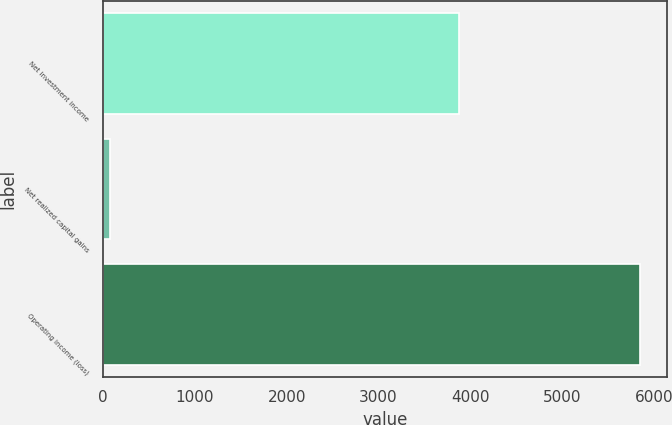Convert chart to OTSL. <chart><loc_0><loc_0><loc_500><loc_500><bar_chart><fcel>Net investment income<fcel>Net realized capital gains<fcel>Operating income (loss)<nl><fcel>3879<fcel>75<fcel>5845<nl></chart> 